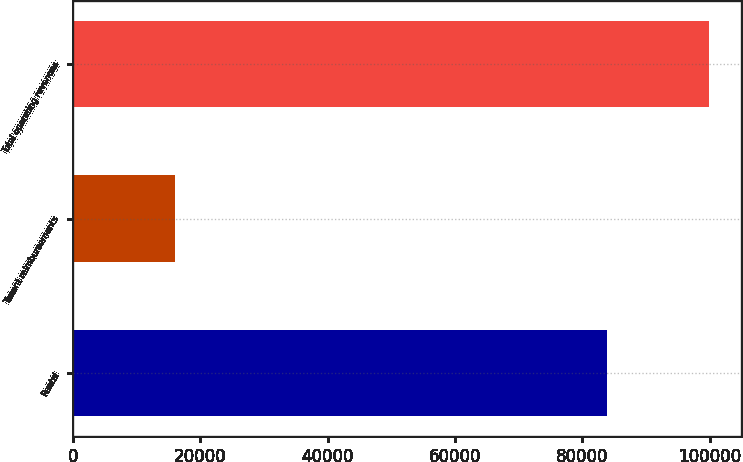Convert chart. <chart><loc_0><loc_0><loc_500><loc_500><bar_chart><fcel>Rental<fcel>Tenant reimbursements<fcel>Total operating revenues<nl><fcel>83869<fcel>16004<fcel>99873<nl></chart> 